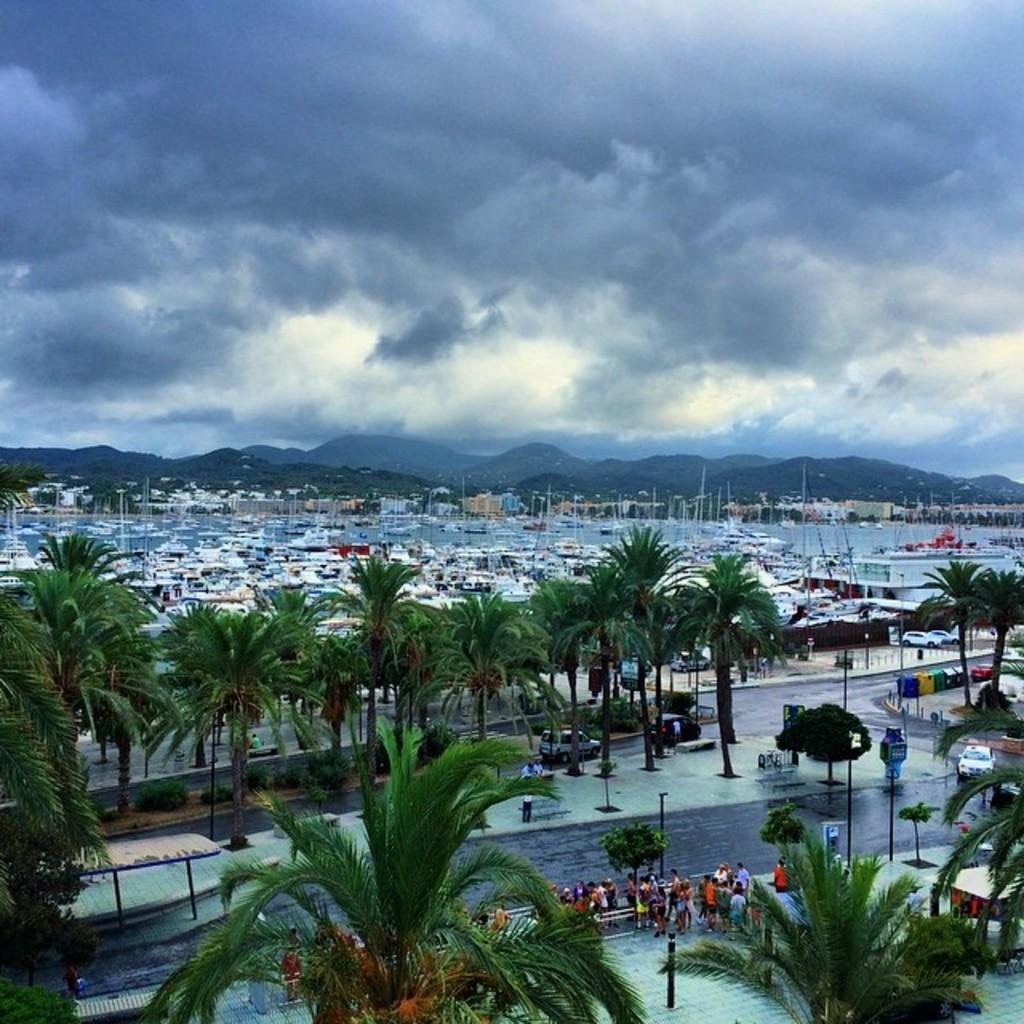How would you summarize this image in a sentence or two? In this image we can see trees. Also there are people. And there are vehicles on the road. In the back we can see boats on the water. In the background there are hills. Also there is sky with clouds. 